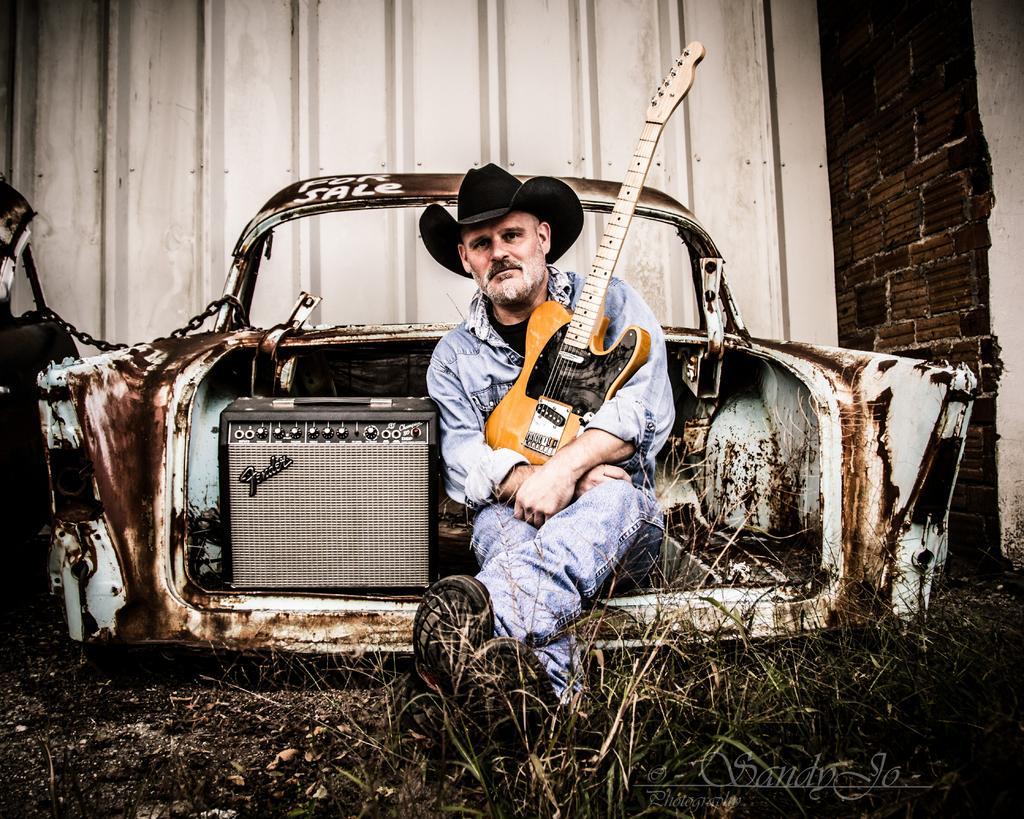Please provide a concise description of this image. there is man sitting in old rusted car holding a guitar. 